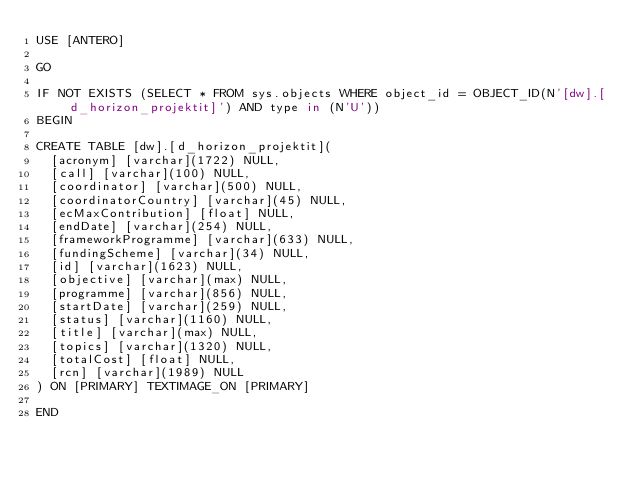<code> <loc_0><loc_0><loc_500><loc_500><_SQL_>USE [ANTERO]

GO

IF NOT EXISTS (SELECT * FROM sys.objects WHERE object_id = OBJECT_ID(N'[dw].[d_horizon_projektit]') AND type in (N'U'))
BEGIN

CREATE TABLE [dw].[d_horizon_projektit](
	[acronym] [varchar](1722) NULL,
	[call] [varchar](100) NULL,
	[coordinator] [varchar](500) NULL,
	[coordinatorCountry] [varchar](45) NULL,
	[ecMaxContribution] [float] NULL,
	[endDate] [varchar](254) NULL,
	[frameworkProgramme] [varchar](633) NULL,
	[fundingScheme] [varchar](34) NULL,
	[id] [varchar](1623) NULL,
	[objective] [varchar](max) NULL,
	[programme] [varchar](856) NULL,
	[startDate] [varchar](259) NULL,
	[status] [varchar](1160) NULL,
	[title] [varchar](max) NULL,
	[topics] [varchar](1320) NULL,
	[totalCost] [float] NULL,
	[rcn] [varchar](1989) NULL
) ON [PRIMARY] TEXTIMAGE_ON [PRIMARY]

END


</code> 